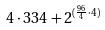Convert formula to latex. <formula><loc_0><loc_0><loc_500><loc_500>4 \cdot 3 3 4 + 2 ^ { ( \frac { 9 6 } { 4 } \cdot 4 ) }</formula> 